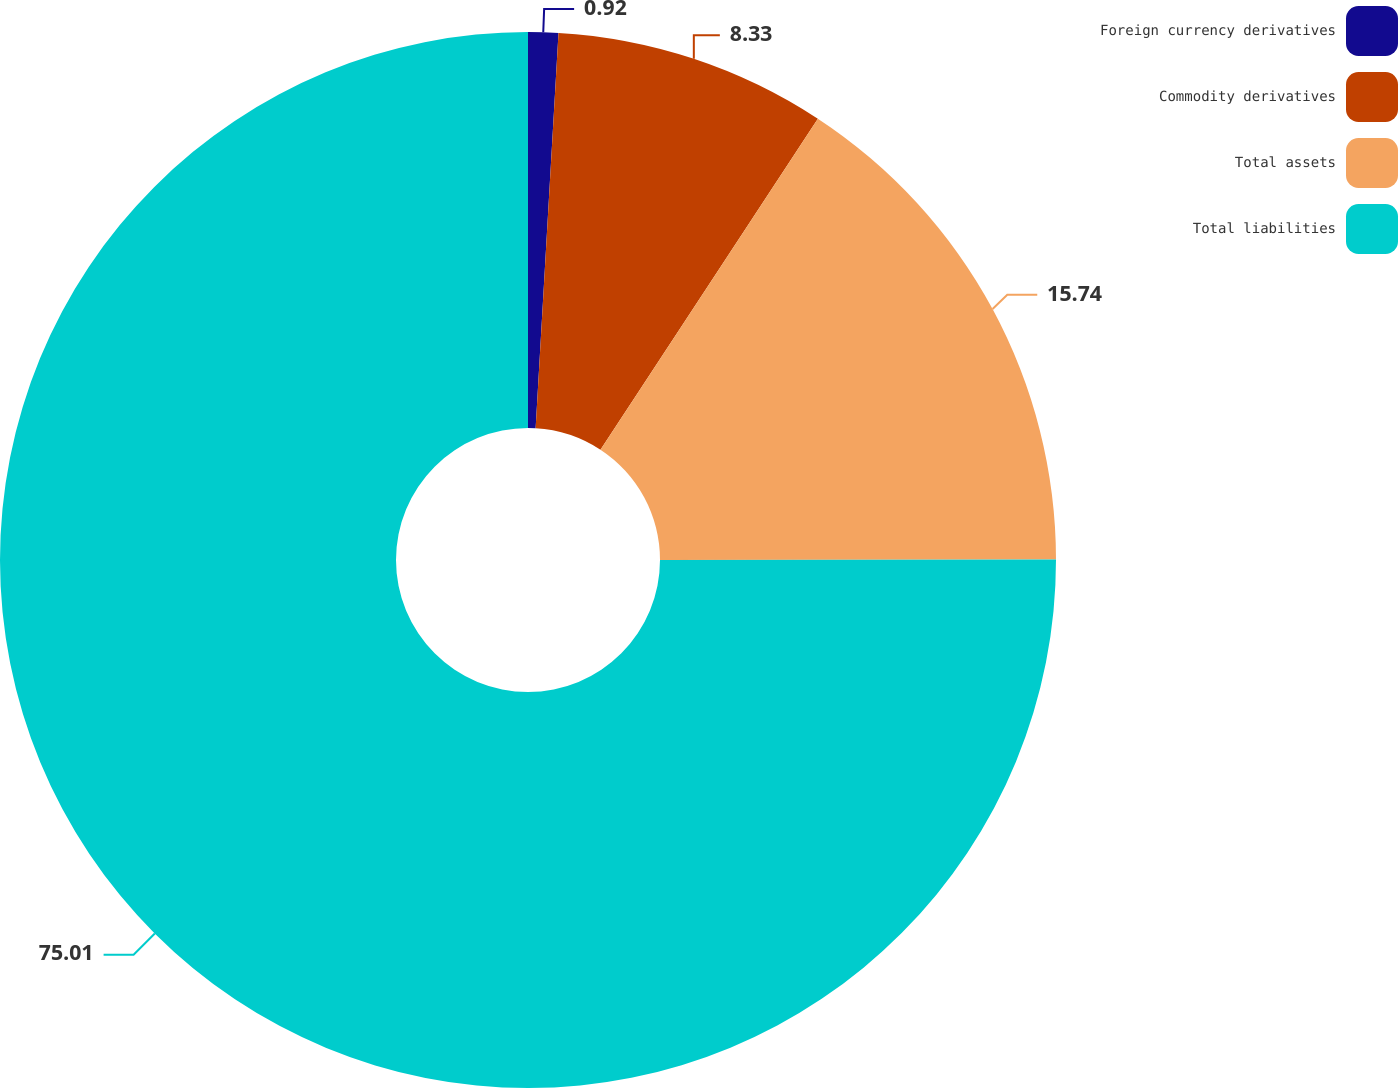Convert chart. <chart><loc_0><loc_0><loc_500><loc_500><pie_chart><fcel>Foreign currency derivatives<fcel>Commodity derivatives<fcel>Total assets<fcel>Total liabilities<nl><fcel>0.92%<fcel>8.33%<fcel>15.74%<fcel>75.02%<nl></chart> 